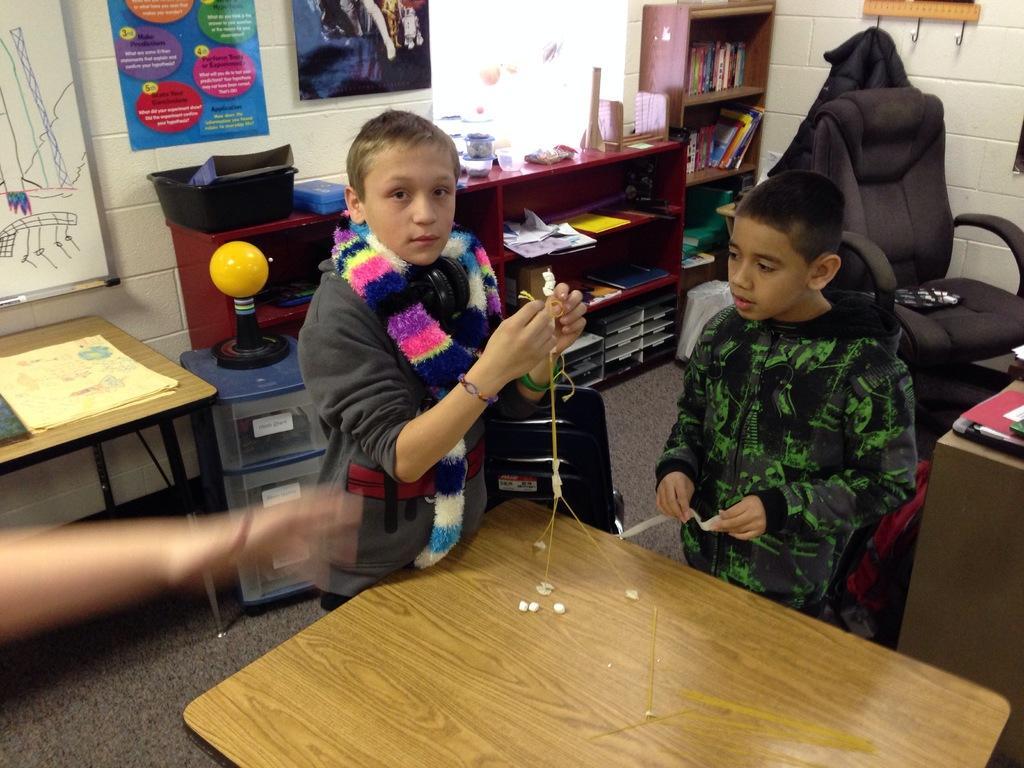Please provide a concise description of this image. In this image i can see two man standing holding a stand on a table at the back ground i can see a chair, few papers and books on a cup board, few papers on a table, there are some banners attached to a wall. 